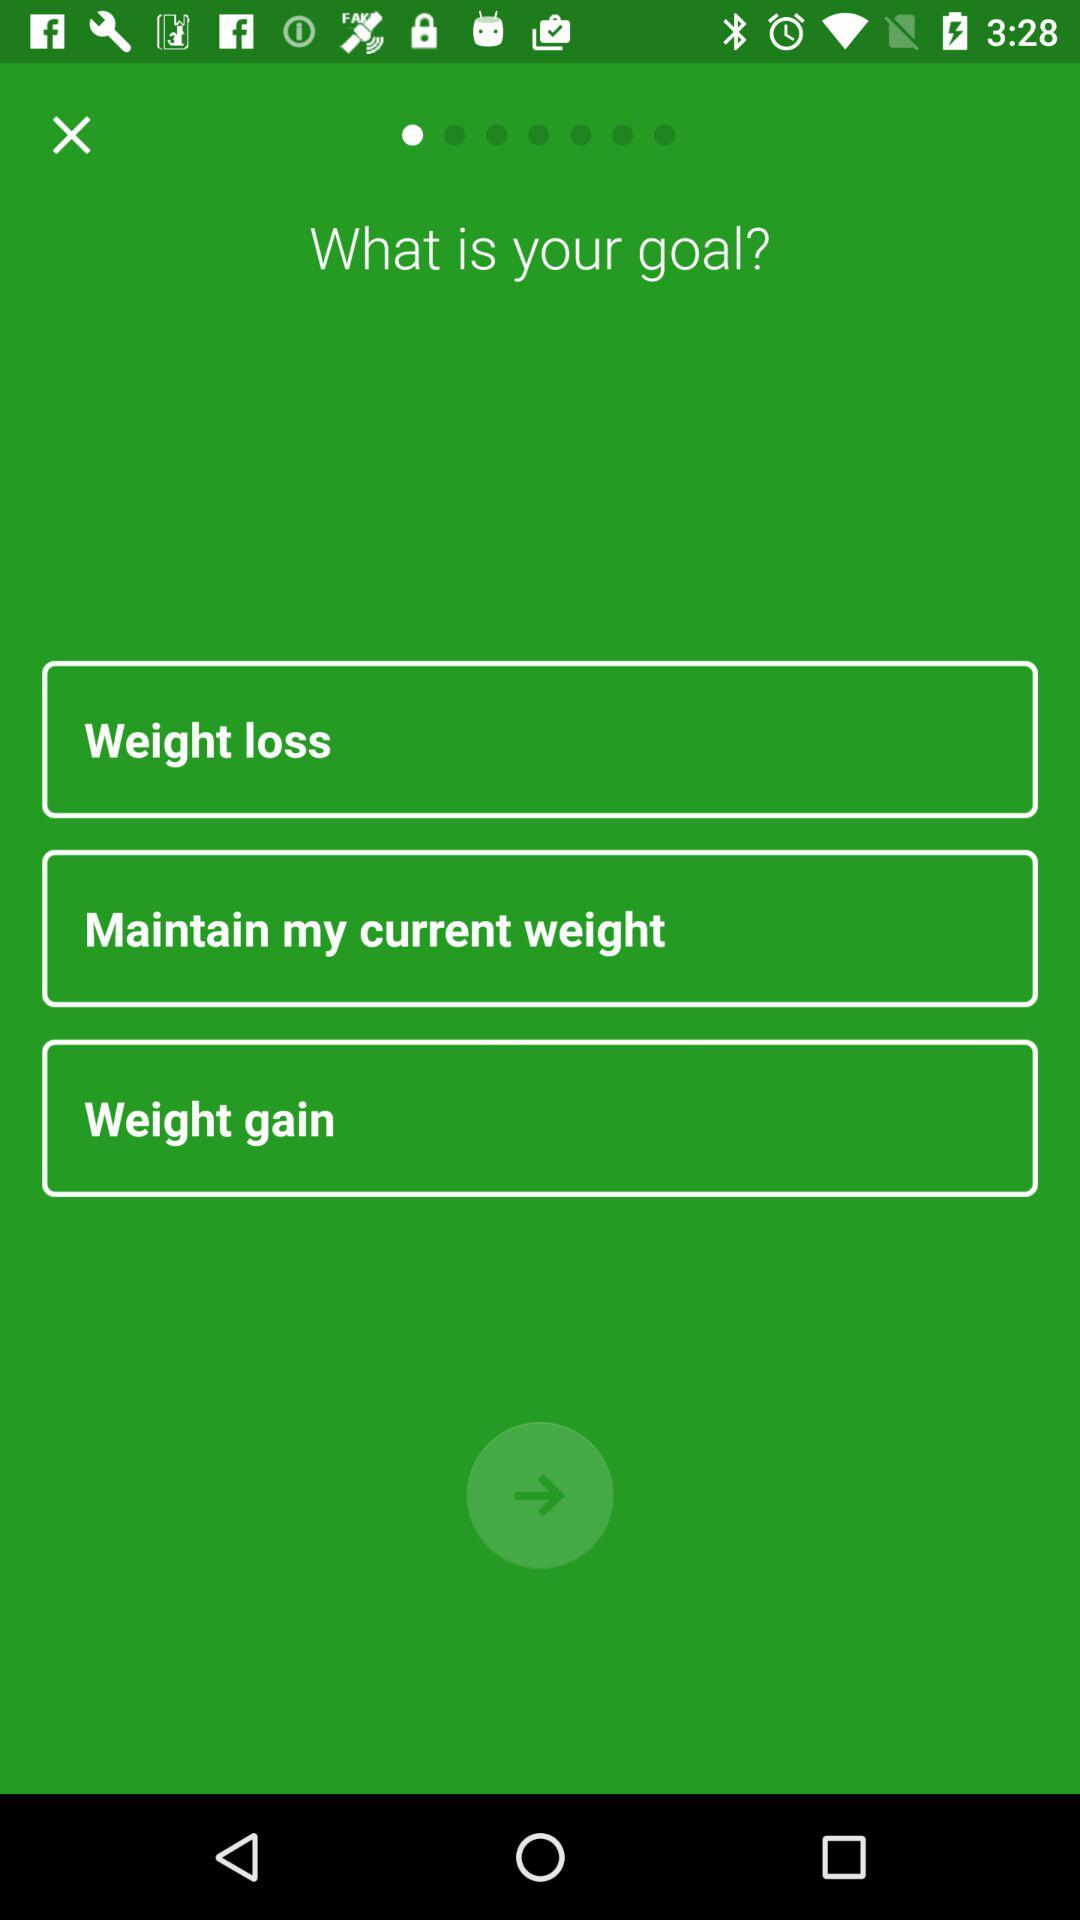What are the options to select for "Goals"? The options to select for "Goals" are "Weight loss", "Maintain my current weight" and "Weight gain". 